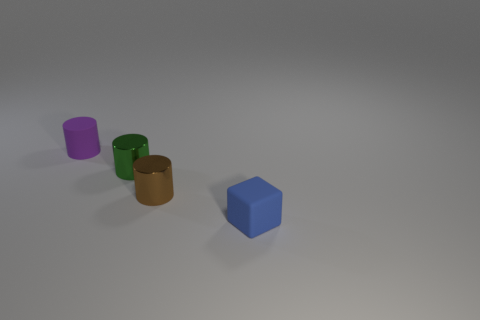Subtract all rubber cylinders. How many cylinders are left? 2 Add 3 small green cylinders. How many objects exist? 7 Subtract all purple cylinders. How many cylinders are left? 2 Subtract all cylinders. How many objects are left? 1 Subtract 2 cylinders. How many cylinders are left? 1 Subtract all red cubes. How many brown cylinders are left? 1 Subtract all cyan cylinders. Subtract all cyan blocks. How many cylinders are left? 3 Subtract all purple things. Subtract all rubber cylinders. How many objects are left? 2 Add 4 tiny brown metallic objects. How many tiny brown metallic objects are left? 5 Add 4 gray rubber things. How many gray rubber things exist? 4 